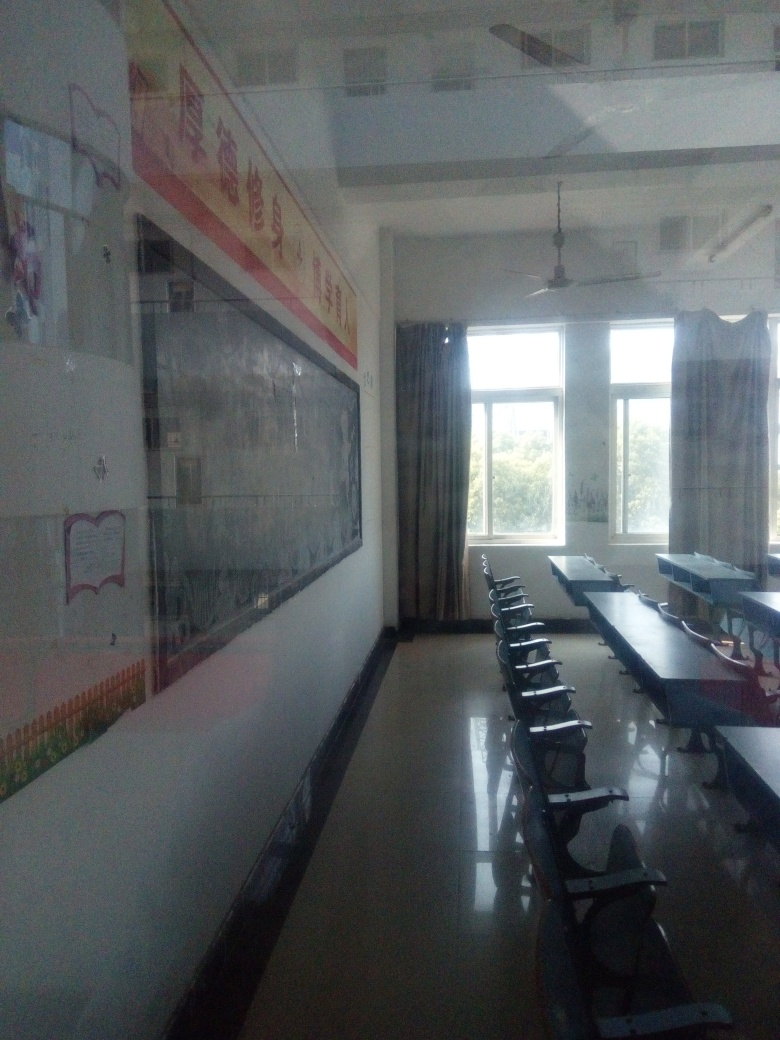What is the mood or atmosphere of the room as conveyed by the image? The atmosphere of the room feels quiet and still, possibly suggesting it is either before students have arrived or after they have left. The absence of people and the tidy arrangement of furniture convey a sense of order and readiness for learning. 